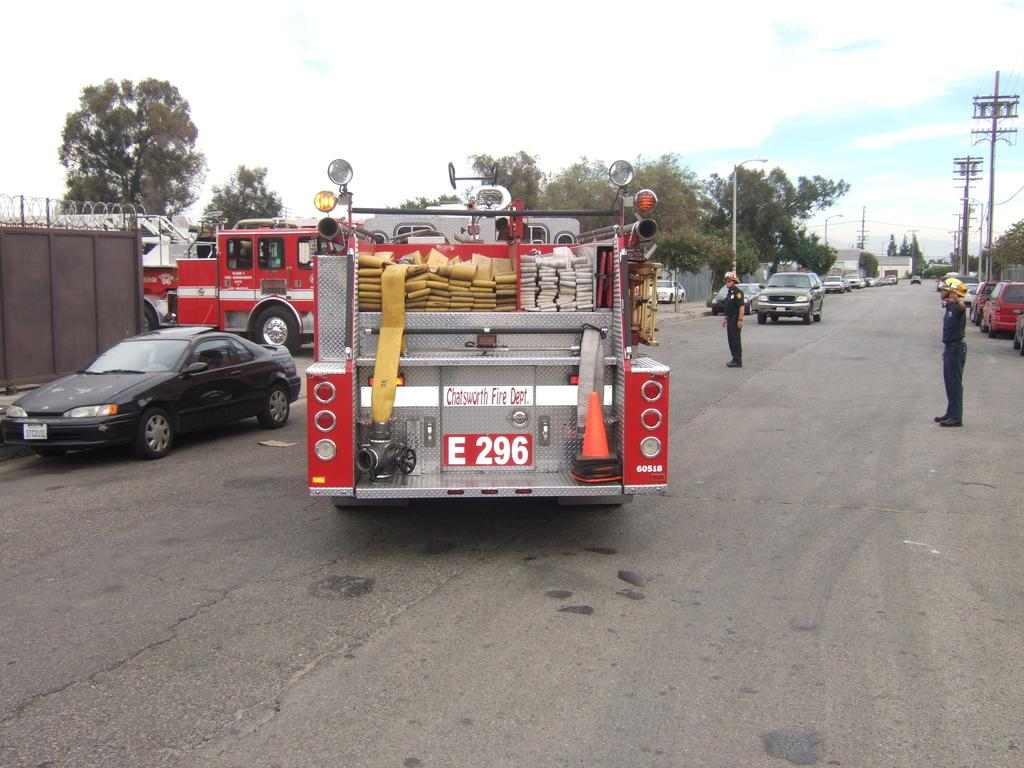What can be seen in the image related to transportation? There are vehicles in the image. Can you describe the people in the image? Two persons are on the road. What is located on the left side of the image? There is a fencing on the left side of the image. What can be seen in the background of the image? There are trees, utility poles, and the sky visible in the background of the image. Where is the crate of potatoes located in the image? There is no crate of potatoes present in the image. What type of stocking is the person wearing on the road? There is no information about any stockings being worn by the persons in the image. 